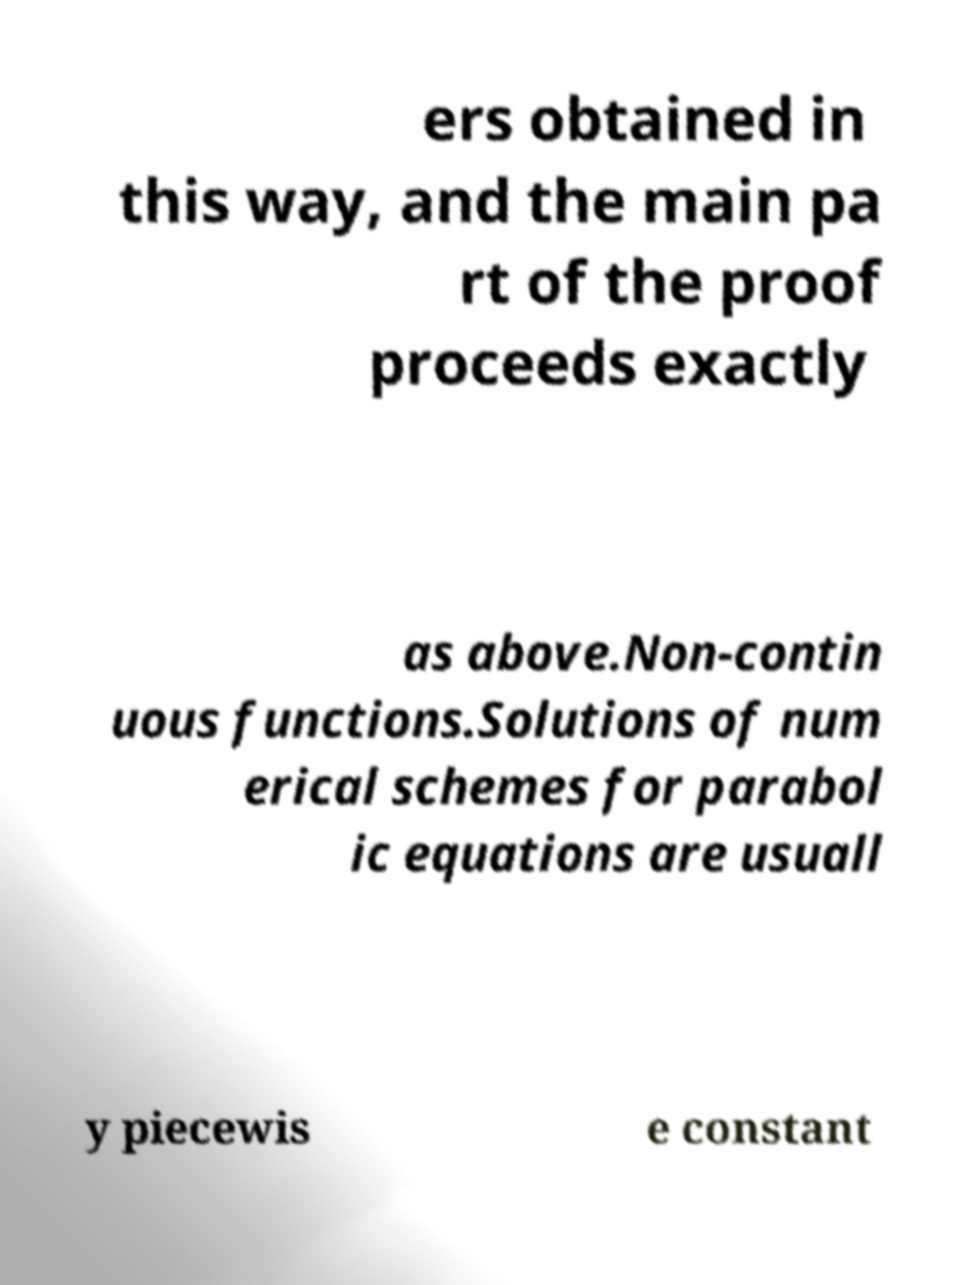There's text embedded in this image that I need extracted. Can you transcribe it verbatim? ers obtained in this way, and the main pa rt of the proof proceeds exactly as above.Non-contin uous functions.Solutions of num erical schemes for parabol ic equations are usuall y piecewis e constant 